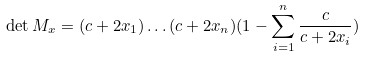<formula> <loc_0><loc_0><loc_500><loc_500>\det M _ { x } = ( c + 2 x _ { 1 } ) \dots ( c + 2 x _ { n } ) ( 1 - \sum _ { i = 1 } ^ { n } \frac { c } { c + 2 x _ { i } } )</formula> 